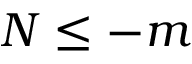Convert formula to latex. <formula><loc_0><loc_0><loc_500><loc_500>N \leq - m</formula> 